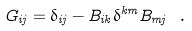<formula> <loc_0><loc_0><loc_500><loc_500>G _ { i j } = \delta _ { i j } - B _ { i k } \delta ^ { k m } B _ { m j } \ .</formula> 